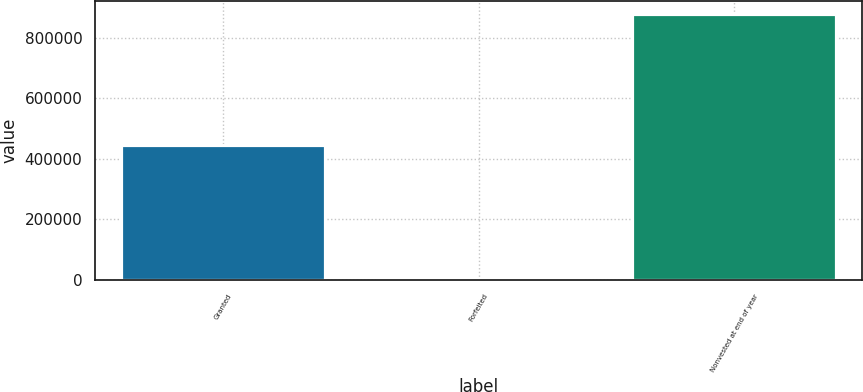Convert chart. <chart><loc_0><loc_0><loc_500><loc_500><bar_chart><fcel>Granted<fcel>Forfeited<fcel>Nonvested at end of year<nl><fcel>444543<fcel>3388<fcel>878104<nl></chart> 